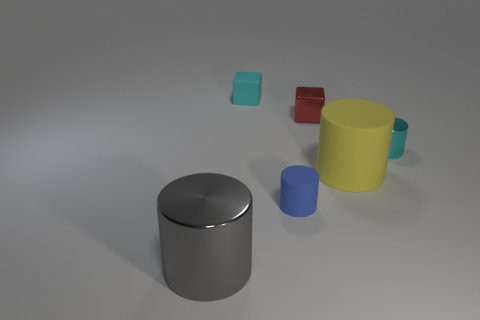There is a cube that is the same color as the tiny metal cylinder; what material is it?
Your response must be concise. Rubber. How many things are both in front of the small cyan metallic cylinder and behind the small blue rubber thing?
Ensure brevity in your answer.  1. Is the shape of the tiny rubber thing that is in front of the yellow matte cylinder the same as  the tiny red metal thing?
Ensure brevity in your answer.  No. What material is the cyan cylinder that is the same size as the red shiny block?
Offer a very short reply. Metal. Is the number of matte cylinders that are left of the red block the same as the number of tiny blue rubber objects that are in front of the tiny cyan cube?
Keep it short and to the point. Yes. There is a metallic thing in front of the cyan thing right of the small cyan rubber object; how many small rubber blocks are on the right side of it?
Give a very brief answer. 1. Is the color of the shiny cube the same as the cube on the left side of the tiny blue object?
Provide a short and direct response. No. What size is the cyan thing that is made of the same material as the yellow object?
Offer a terse response. Small. Is the number of shiny cylinders in front of the cyan cylinder greater than the number of metal balls?
Offer a terse response. Yes. What is the material of the tiny cyan object that is right of the small matte thing to the right of the cyan object that is on the left side of the small shiny cylinder?
Your response must be concise. Metal. 